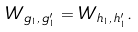Convert formula to latex. <formula><loc_0><loc_0><loc_500><loc_500>W _ { g _ { 1 } , \, g _ { 1 } ^ { \prime } } = W _ { h _ { 1 } , \, h _ { 1 } ^ { \prime } } .</formula> 